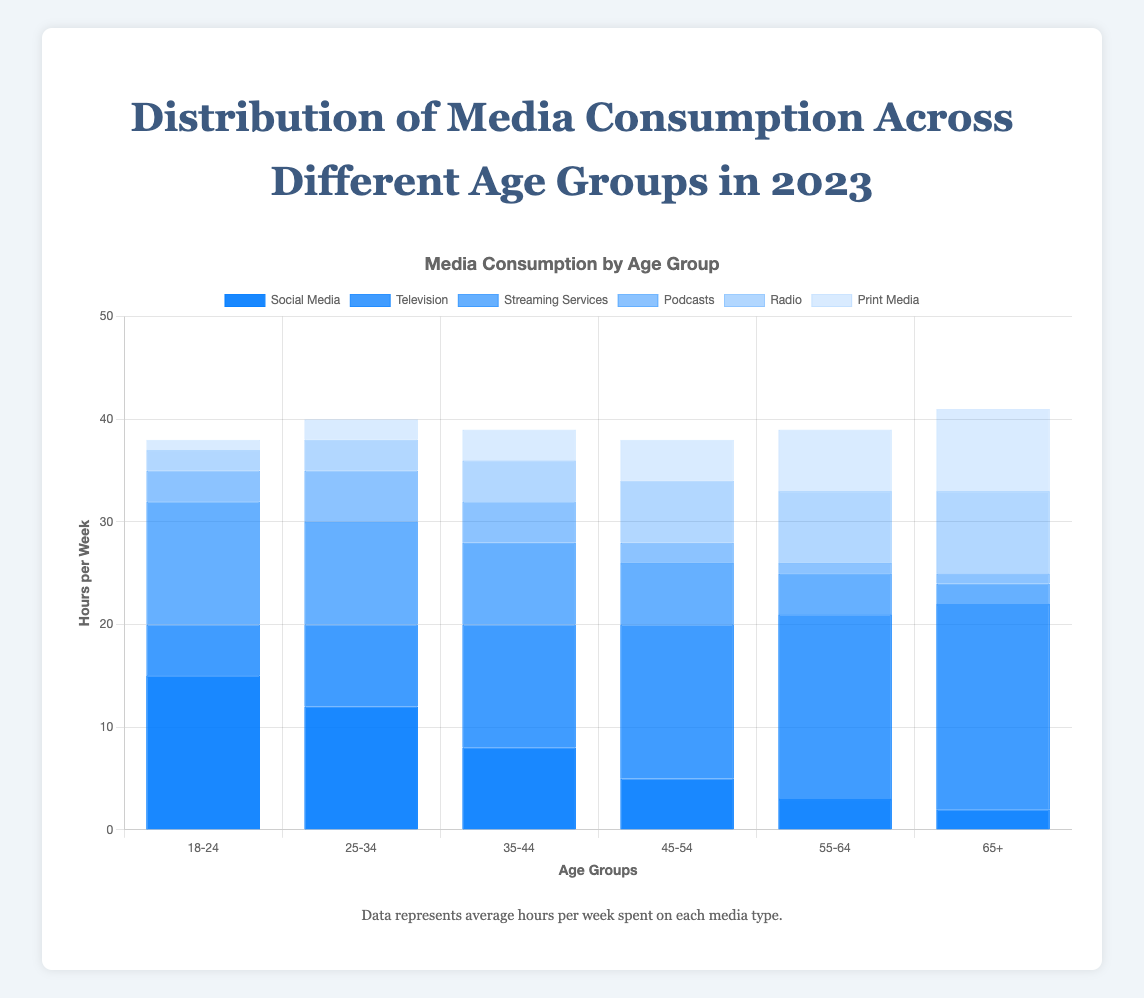Which age group has the highest overall media consumption? To find the highest overall media consumption, sum the hours per week for each type of media within each age group:
18-24: 15+5+12+3+2+1 = 38,
25-34: 12+8+10+5+3+2 = 40,
35-44: 8+12+8+4+4+3 = 39,
45-54: 5+15+6+2+6+4 = 38,
55-64: 3+18+4+1+7+6 = 39,
65+: 2+20+2+1+8+8 = 41.
The age group 65+ has the highest overall media consumption.
Answer: 65+ Which media type sees the most significant decline in consumption from the youngest age group (18-24) to the oldest age group (65+)? Compare the consumption of each media type between the 18-24 and 65+ age groups:
Social Media: 15 - 2 = 13,
Television: 5 - 20 = -15,
Streaming Services: 12 - 2 = 10,
Podcasts: 3 - 1 = 2,
Radio: 2 - 8 = -6,
Print Media: 1 - 8 = -7.
Television sees the most significant increase (negative decline) in consumption from 18-24 to 65+.
Answer: Television What is the combined total hours per week spent on Social Media for all age groups? Sum the hours per week spent on Social Media by each age group:
18-24: 15,
25-34: 12,
35-44: 8,
45-54: 5,
55-64: 3,
65+: 2.
The total is 15 + 12 + 8 + 5 + 3 + 2 = 45.
Answer: 45 Which age group spends the most hours per week on Podcasts compared to others? Check the hours per week spent on Podcasts for each age group:
18-24: 3,
25-34: 5,
35-44: 4,
45-54: 2,
55-64: 1,
65+: 1.
The 25-34 age group spends the most hours per week on Podcasts.
Answer: 25-34 Across all age groups, which has a higher average weekly consumption: Radio or Print Media? Calculate the average weekly consumption for Radio and Print Media using the totals divided by the number of age groups (6):
Radio: (2+3+4+6+7+8)/6 = 5,
Print Media: (1+2+3+4+6+8)/6 = 4.
Radio has a higher average weekly consumption.
Answer: Radio For the age group 45-54, what is the difference between the hours spent on Television and Streaming Services? Subtract the hours spent on Streaming Services from the hours spent on Television for the 45-54 age group:
Television: 15,
Streaming Services: 6.
Thus, 15 - 6 = 9.
Answer: 9 